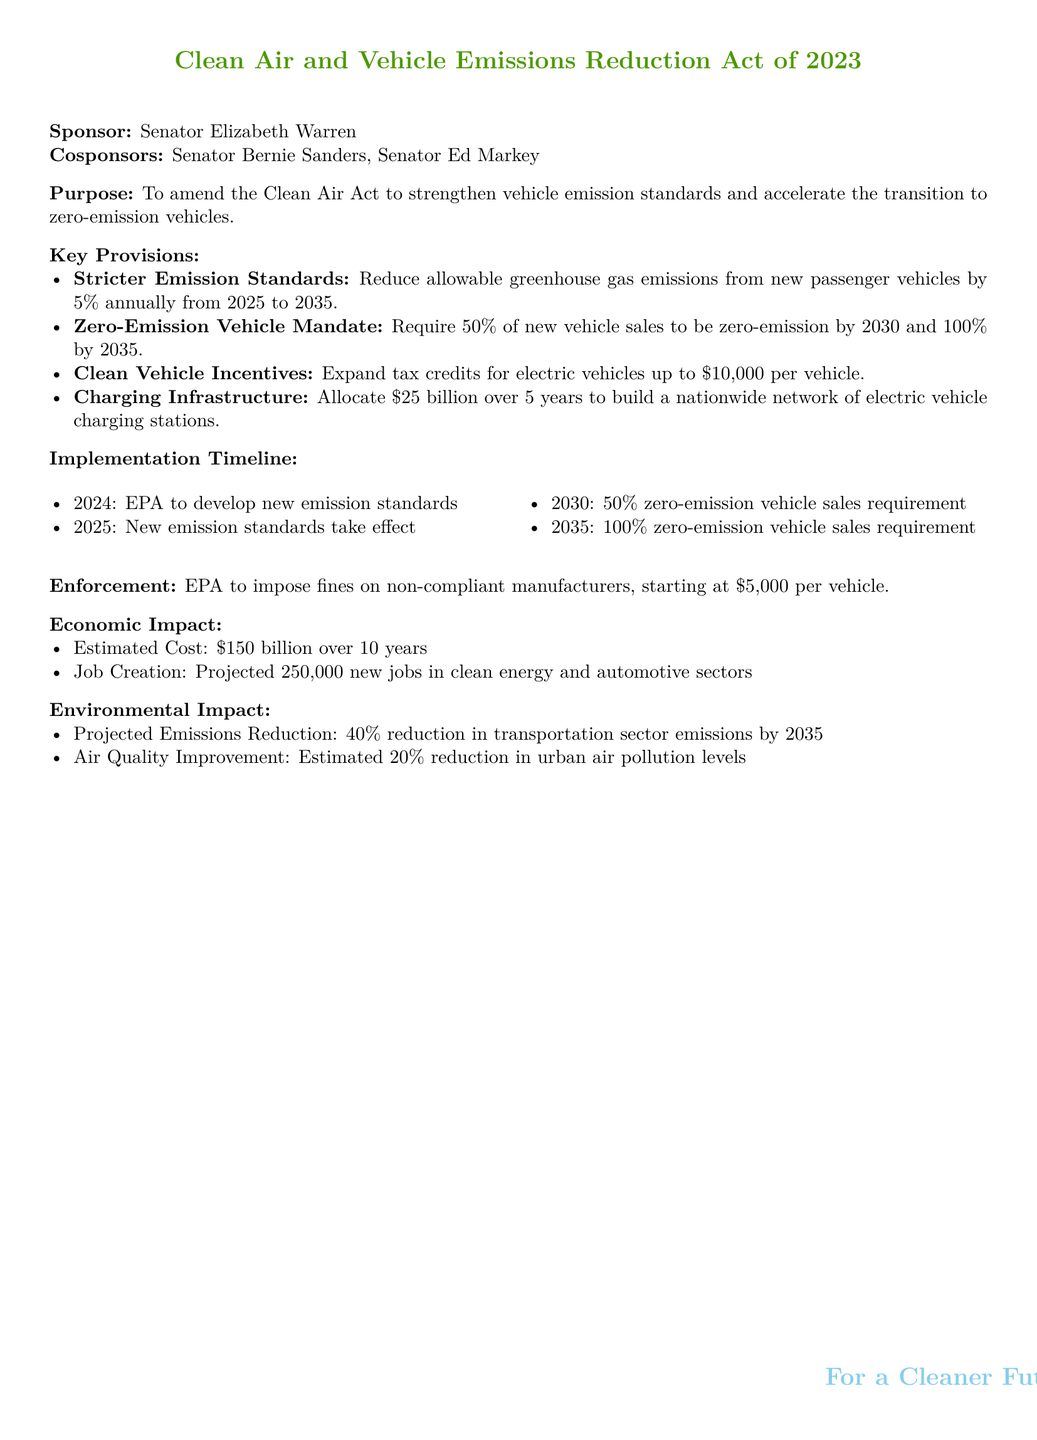What is the title of the bill? The title of the bill is presented at the beginning, clearly indicating its purpose regarding air quality and vehicle emissions.
Answer: Clean Air and Vehicle Emissions Reduction Act of 2023 Who is the primary sponsor of the bill? The primary sponsor of the bill is mentioned in the document, indicating the main legislator supporting its introduction.
Answer: Senator Elizabeth Warren What is the deadline for the 50% zero-emission vehicle sales requirement? The document specifies the year by which the 50% target must be achieved, providing a clear timeline for stakeholders.
Answer: 2030 What is the estimated cost of the bill over ten years? The estimated cost is provided for the implementation and associated initiatives of the bill, highlighting potential financial commitments.
Answer: $150 billion How much funding is allocated for charging infrastructure? The document outlines the amount set aside specifically for building a nationwide network of charging stations.
Answer: $25 billion What reduction in transportation sector emissions is projected by 2035? The document states the percent reduction expected in terms of emissions, key for assessing environmental impacts.
Answer: 40% What is the fine for non-compliant manufacturers? The document specifies the starting financial penalty for manufacturers that do not comply with the new standards established by the bill.
Answer: $5,000 Who is responsible for developing new emission standards? The document assigns responsibility for this task to a specific agency, ensuring accountability in the bill's implementation.
Answer: EPA What are the projected new jobs in the clean energy sector? The document highlights the job creation potential within the sectors affected by the bill, emphasizing economic benefits.
Answer: 250,000 